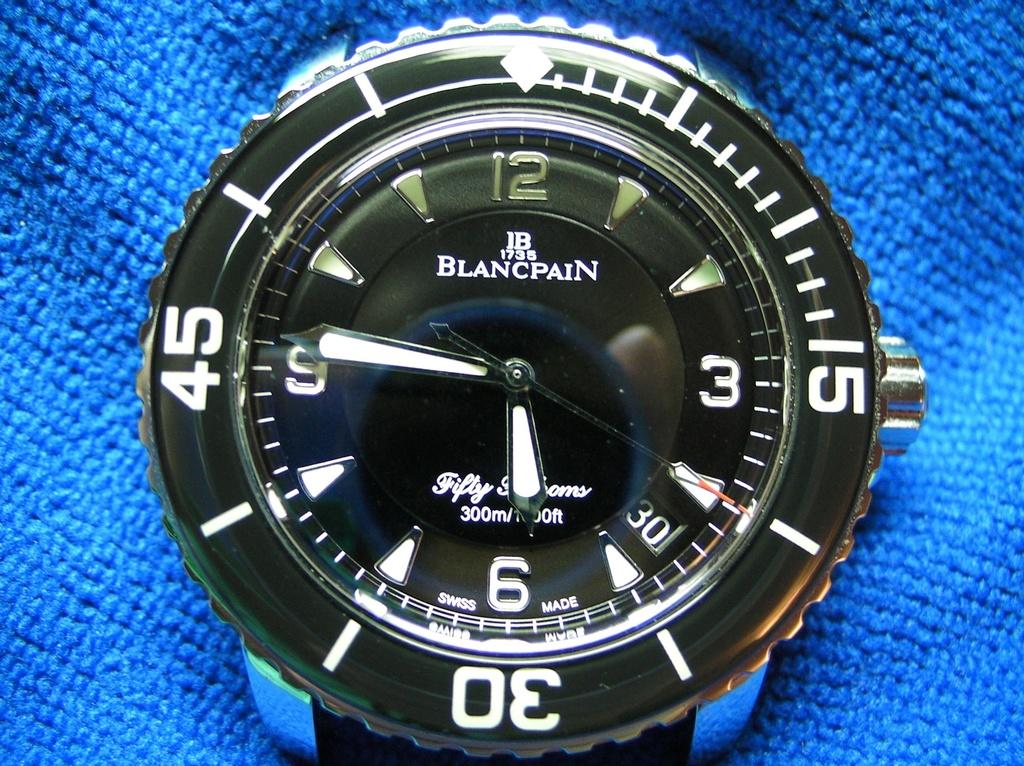<image>
Share a concise interpretation of the image provided. A Blancpain watch face sits on a bright blue cloth. 